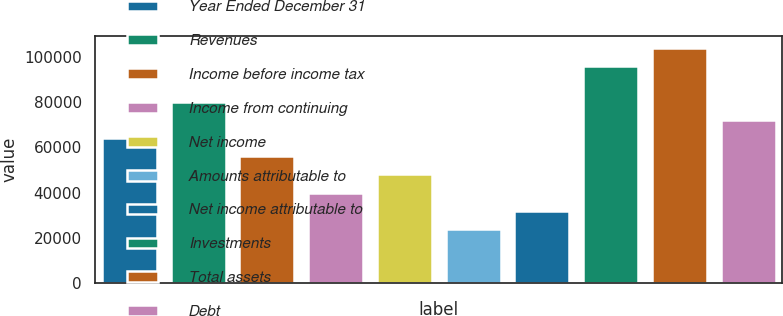Convert chart. <chart><loc_0><loc_0><loc_500><loc_500><bar_chart><fcel>Year Ended December 31<fcel>Revenues<fcel>Income before income tax<fcel>Income from continuing<fcel>Net income<fcel>Amounts attributable to<fcel>Net income attributable to<fcel>Investments<fcel>Total assets<fcel>Debt<nl><fcel>64016.9<fcel>80021<fcel>56014.8<fcel>40010.7<fcel>48012.7<fcel>24006.5<fcel>32008.6<fcel>96025.2<fcel>104027<fcel>72019<nl></chart> 